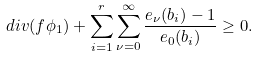<formula> <loc_0><loc_0><loc_500><loc_500>d i v ( f \phi _ { 1 } ) + \sum _ { i = 1 } ^ { r } \sum _ { \nu = 0 } ^ { \infty } \frac { e _ { \nu } ( b _ { i } ) - 1 } { e _ { 0 } ( b _ { i } ) } \geq 0 .</formula> 